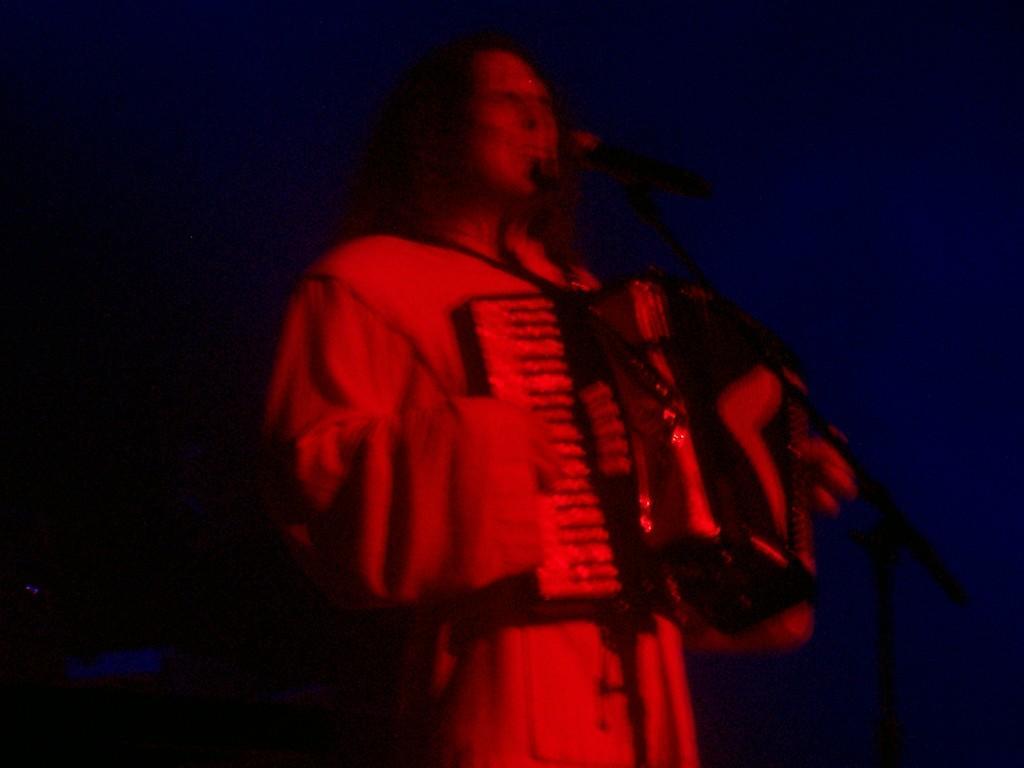Could you give a brief overview of what you see in this image? In this image we can see a person playing a musical instrument, in front to him there is a mic, and the background is dark. 